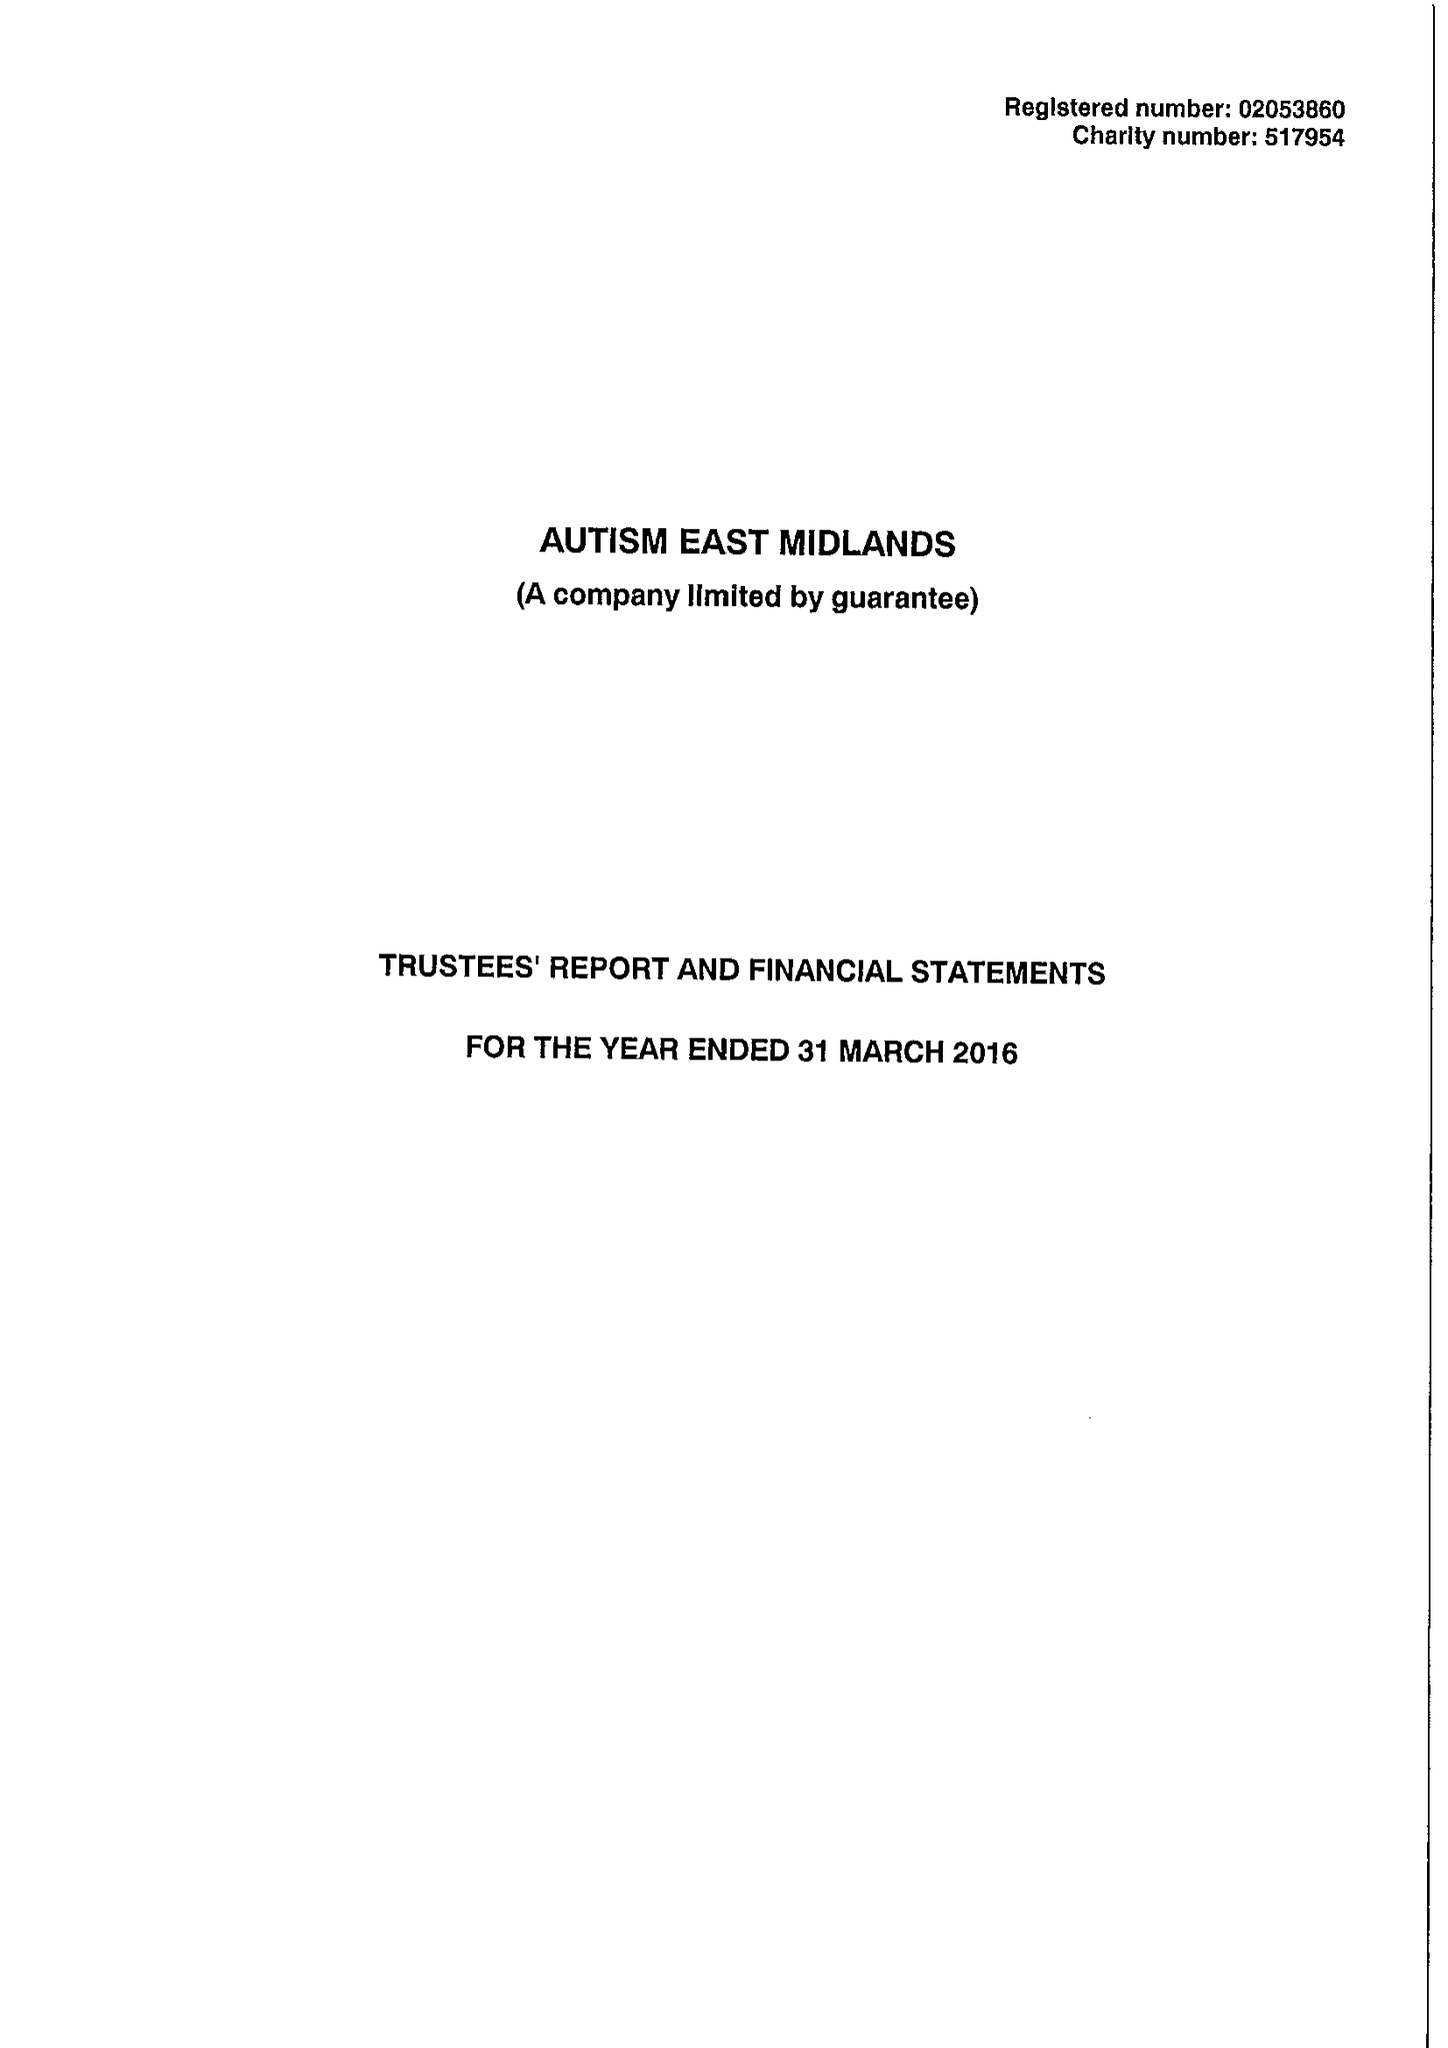What is the value for the charity_name?
Answer the question using a single word or phrase. Autism East Midlands 